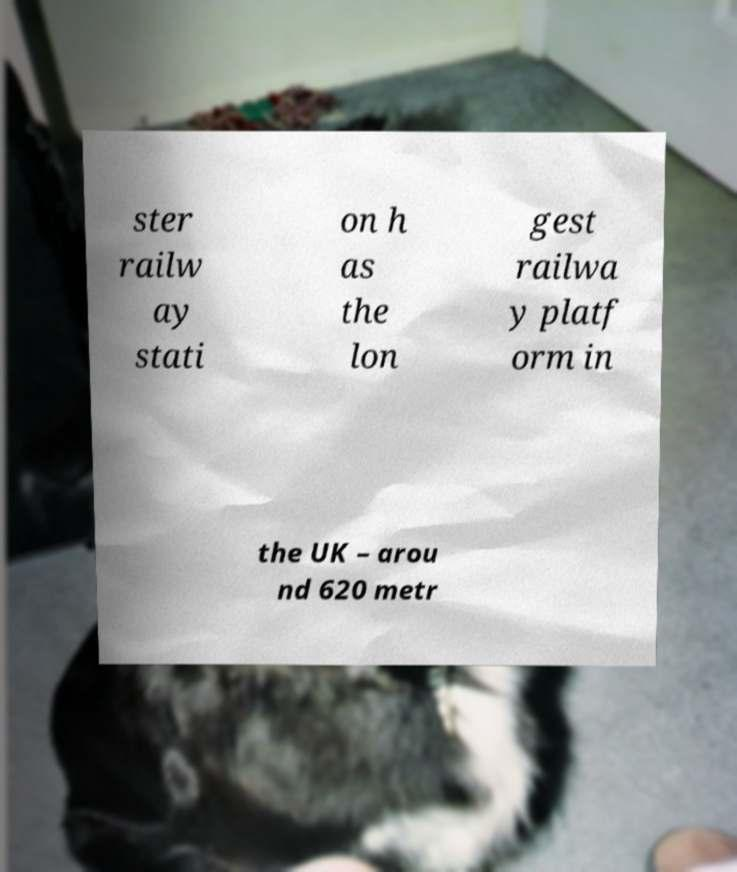Please identify and transcribe the text found in this image. ster railw ay stati on h as the lon gest railwa y platf orm in the UK – arou nd 620 metr 